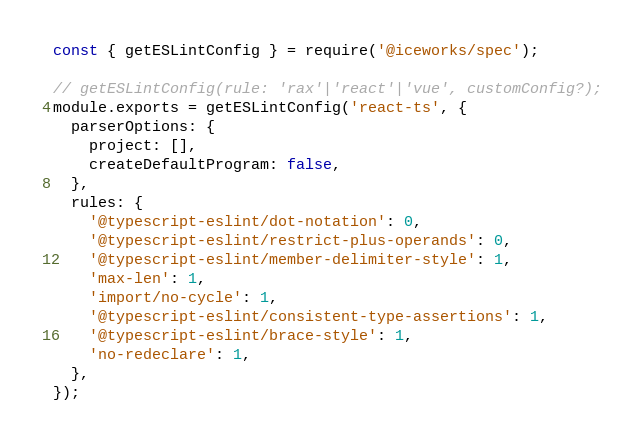Convert code to text. <code><loc_0><loc_0><loc_500><loc_500><_JavaScript_>const { getESLintConfig } = require('@iceworks/spec');

// getESLintConfig(rule: 'rax'|'react'|'vue', customConfig?);
module.exports = getESLintConfig('react-ts', {
  parserOptions: {
    project: [],
    createDefaultProgram: false,
  },
  rules: {
    '@typescript-eslint/dot-notation': 0,
    '@typescript-eslint/restrict-plus-operands': 0,
    '@typescript-eslint/member-delimiter-style': 1,
    'max-len': 1,
    'import/no-cycle': 1,
    '@typescript-eslint/consistent-type-assertions': 1,
    '@typescript-eslint/brace-style': 1,
    'no-redeclare': 1,
  },
});
</code> 